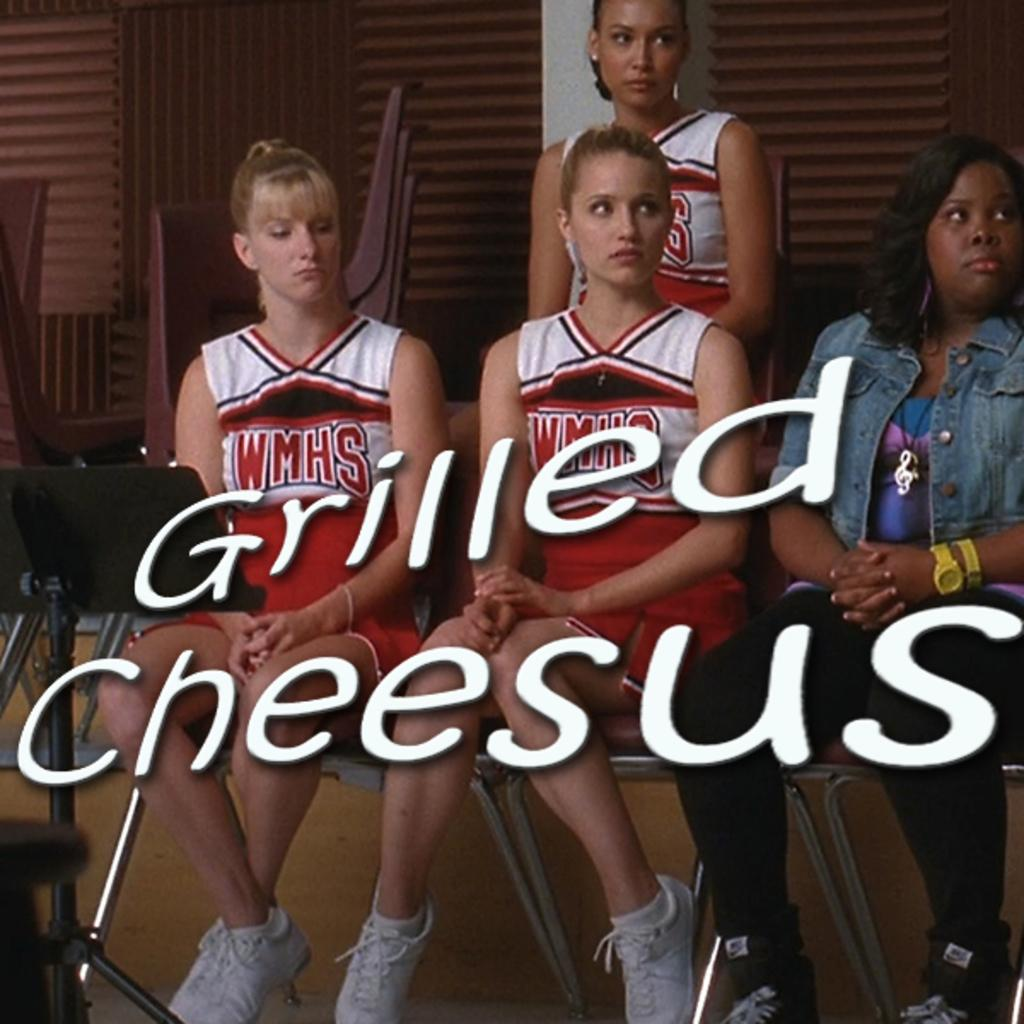<image>
Create a compact narrative representing the image presented. Cheerleaders wear uniforms with the initials WMHS on the front. 